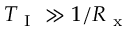Convert formula to latex. <formula><loc_0><loc_0><loc_500><loc_500>T _ { I } \gg 1 / R _ { x }</formula> 